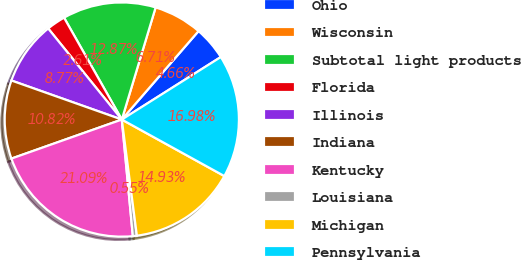Convert chart to OTSL. <chart><loc_0><loc_0><loc_500><loc_500><pie_chart><fcel>Ohio<fcel>Wisconsin<fcel>Subtotal light products<fcel>Florida<fcel>Illinois<fcel>Indiana<fcel>Kentucky<fcel>Louisiana<fcel>Michigan<fcel>Pennsylvania<nl><fcel>4.66%<fcel>6.71%<fcel>12.87%<fcel>2.61%<fcel>8.77%<fcel>10.82%<fcel>21.09%<fcel>0.55%<fcel>14.93%<fcel>16.98%<nl></chart> 